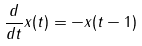Convert formula to latex. <formula><loc_0><loc_0><loc_500><loc_500>\frac { d } { d t } x ( t ) = - x ( t - 1 )</formula> 